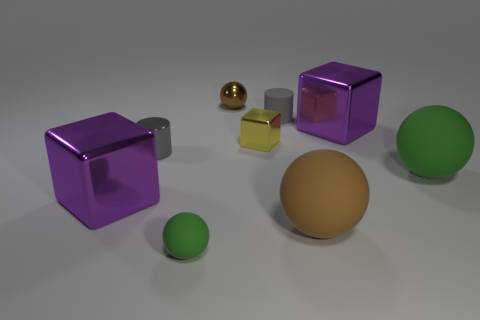There is a matte object to the right of the big purple shiny block to the right of the gray metal cylinder; what color is it?
Offer a very short reply. Green. Is the size of the gray matte object the same as the yellow shiny object?
Provide a succinct answer. Yes. What number of balls are small green matte things or small shiny things?
Provide a succinct answer. 2. What number of rubber spheres are to the left of the green rubber ball to the left of the small brown sphere?
Your answer should be compact. 0. Is the small green rubber object the same shape as the large green thing?
Provide a succinct answer. Yes. There is another thing that is the same shape as the tiny gray metal thing; what is its size?
Ensure brevity in your answer.  Small. The large purple thing that is on the left side of the green rubber sphere that is to the left of the brown rubber object is what shape?
Offer a terse response. Cube. The yellow metallic cube has what size?
Make the answer very short. Small. What is the shape of the large brown object?
Make the answer very short. Sphere. Is the shape of the big green object the same as the tiny rubber object that is left of the tiny brown ball?
Offer a terse response. Yes. 